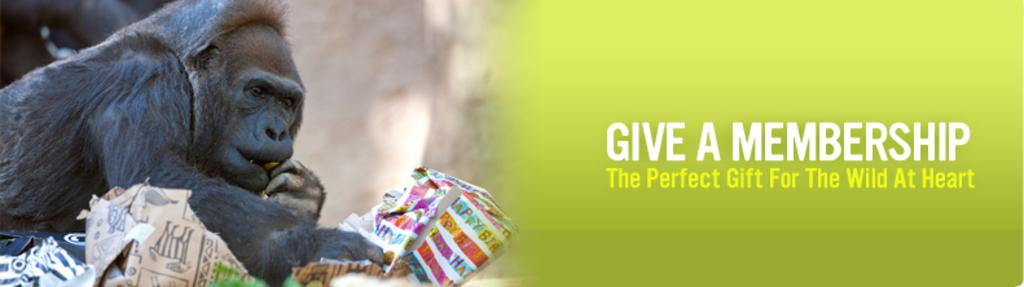What is the animal holding in the image? There is an animal holding an object in the image. What else can be seen on the right side of the image? There is text on the right side of the image. Are there any small creatures visible in the image? Yes, there are bugs visible at the bottom of the image. What type of toothpaste is being used to put out the fire in the image? There is no fire or toothpaste present in the image. 